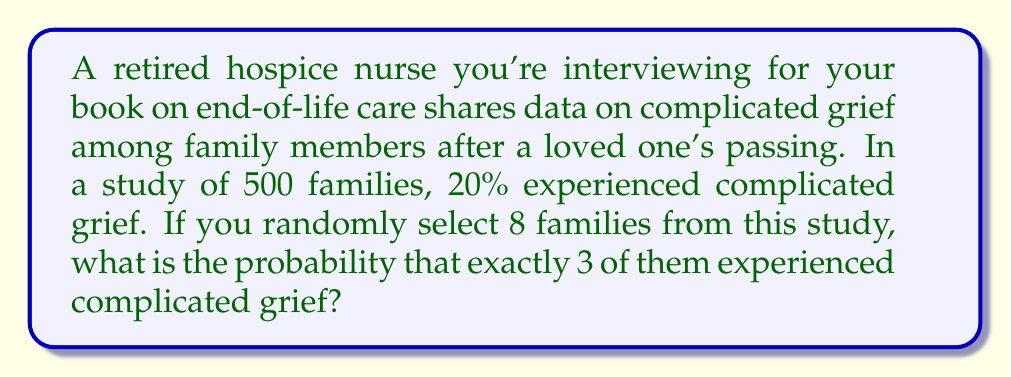Teach me how to tackle this problem. To solve this problem, we need to use the binomial probability distribution, as we're dealing with a fixed number of independent trials (selecting 8 families) with two possible outcomes for each trial (experiencing complicated grief or not).

Let's define our variables:
$n = 8$ (number of families selected)
$k = 3$ (number of families we want to experience complicated grief)
$p = 0.20$ (probability of a family experiencing complicated grief)
$q = 1 - p = 0.80$ (probability of a family not experiencing complicated grief)

The binomial probability formula is:

$$ P(X = k) = \binom{n}{k} p^k q^{n-k} $$

Where $\binom{n}{k}$ is the binomial coefficient, calculated as:

$$ \binom{n}{k} = \frac{n!}{k!(n-k)!} $$

Let's calculate step by step:

1) First, calculate the binomial coefficient:
   $\binom{8}{3} = \frac{8!}{3!(8-3)!} = \frac{8!}{3!5!} = 56$

2) Now, let's plug everything into the binomial probability formula:
   $P(X = 3) = 56 \cdot (0.20)^3 \cdot (0.80)^{8-3}$
   
3) Simplify:
   $P(X = 3) = 56 \cdot (0.20)^3 \cdot (0.80)^5$
   
4) Calculate:
   $P(X = 3) = 56 \cdot 0.008 \cdot 0.32768 = 0.1468$

Therefore, the probability of exactly 3 out of 8 randomly selected families experiencing complicated grief is approximately 0.1468 or 14.68%.
Answer: $0.1468$ or $14.68\%$ 